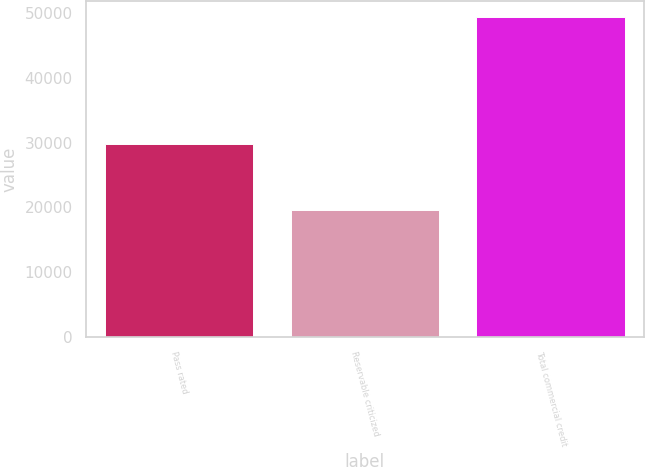Convert chart to OTSL. <chart><loc_0><loc_0><loc_500><loc_500><bar_chart><fcel>Pass rated<fcel>Reservable criticized<fcel>Total commercial credit<nl><fcel>29757<fcel>19636<fcel>49393<nl></chart> 